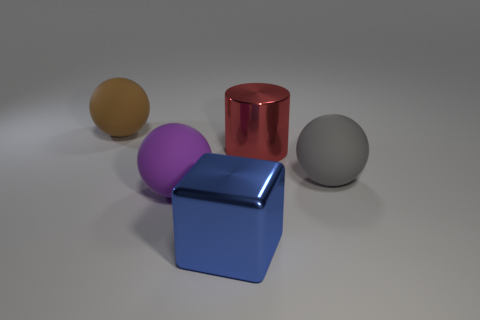Add 1 big shiny balls. How many objects exist? 6 Subtract all cylinders. How many objects are left? 4 Add 1 cyan metallic spheres. How many cyan metallic spheres exist? 1 Subtract 0 green cylinders. How many objects are left? 5 Subtract all big gray objects. Subtract all big metal objects. How many objects are left? 2 Add 1 big red things. How many big red things are left? 2 